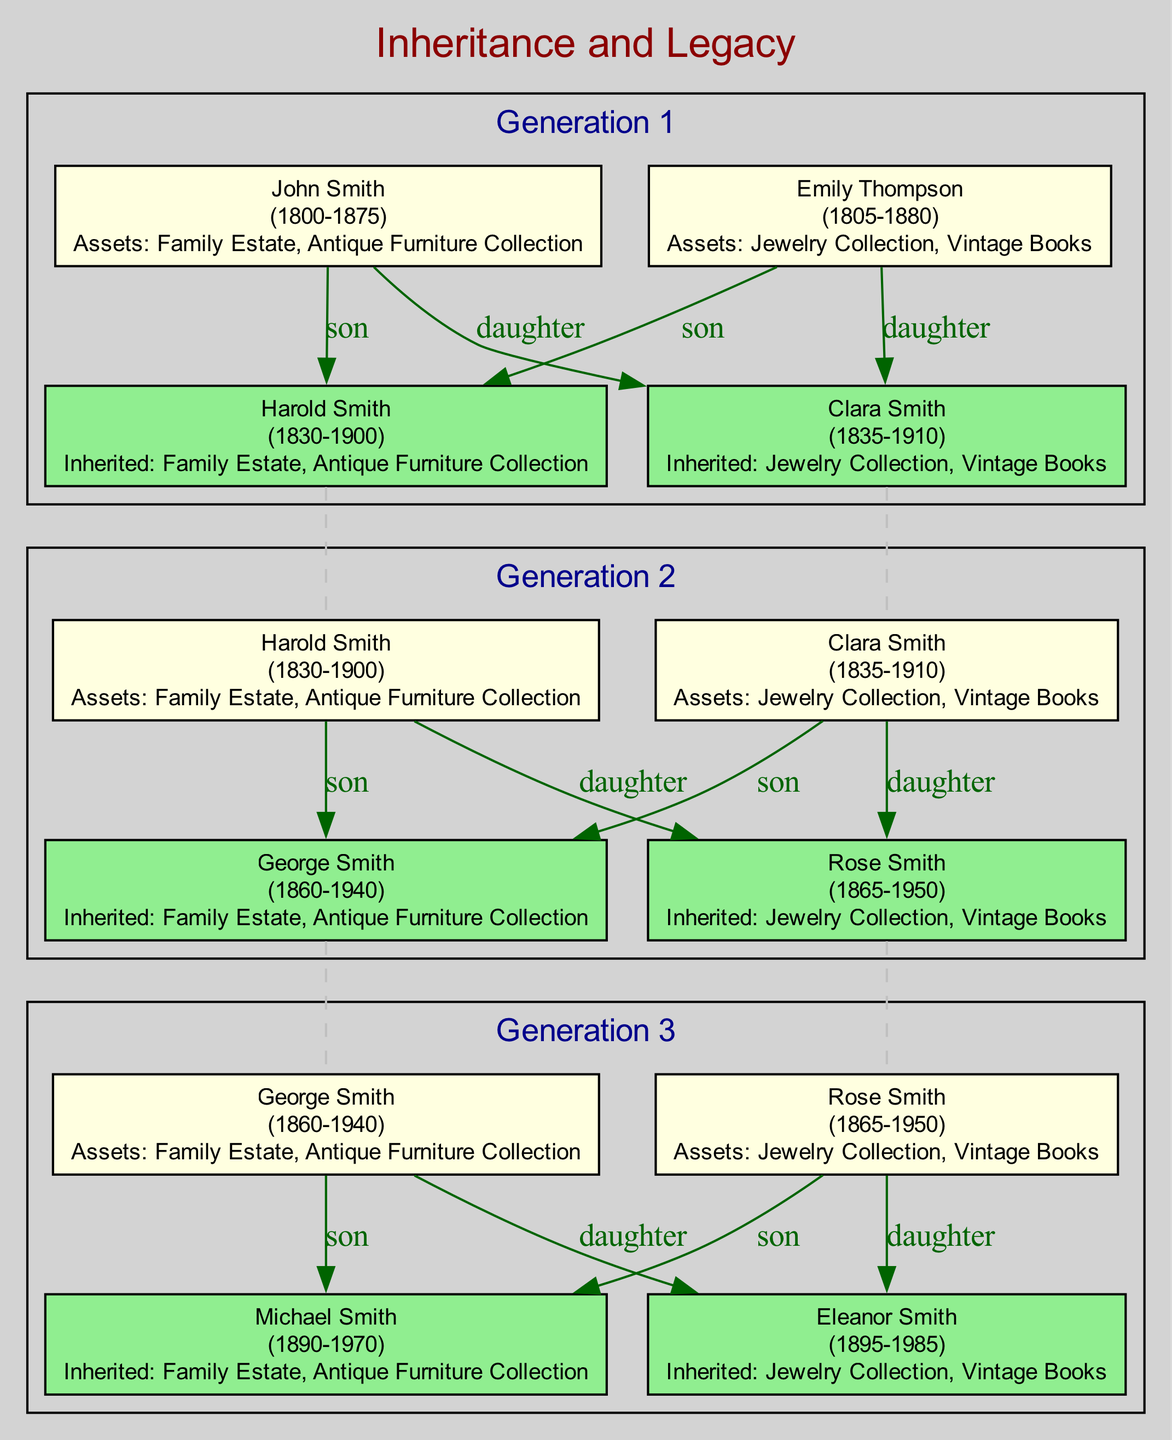What is the name of the first originator? The first originator in the family tree is John Smith, as he is listed in the first generation's originators section.
Answer: John Smith How many beneficiaries are there in the second generation? The second generation has two beneficiaries: George Smith and Rose Smith. This can be confirmed by counting the entries under the beneficiaries section of that generation.
Answer: 2 What assets did Emily Thompson pass down? Emily Thompson's inherited assets are the Jewelry Collection and Vintage Books, which can be found listed under her name in the first generation's originators.
Answer: Jewelry Collection, Vintage Books Who inherited the Family Estate in the third generation? Michael Smith inherited the Family Estate in the third generation, as indicated under the inherited assets next to his name.
Answer: Michael Smith What is the birth year of Clara Smith? Clara Smith's birth year is 1835, directly stated in the originators section of the first generation.
Answer: 1835 Which generation has the highest number of originators? The first generation has the highest number of originators, with two originators listed: John Smith and Emily Thompson. This can be determined by comparing the counts of the originators in each generation.
Answer: 1 What relationship is George Smith to Harold Smith? George Smith is the son of Harold Smith, as specified in the beneficiary relationship part of the second generation.
Answer: son How many assets did each of the beneficiaries in the first generation inherit? Each beneficiary in the first generation inherited two assets, as per the lists next to Harold Smith and Clara Smith in the inherited assets section.
Answer: 2 Which assets did Harold Smith inherit? Harold Smith inherited the Family Estate and Antique Furniture Collection, confirmed by the inherited assets next to his name in the beneficiary section of the first generation.
Answer: Family Estate, Antique Furniture Collection 